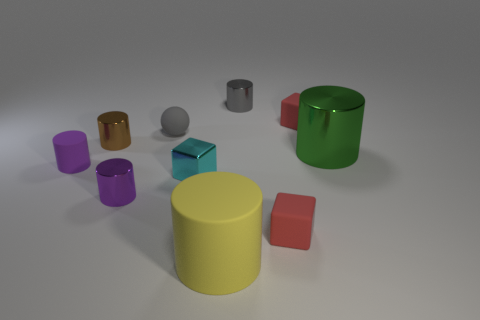Subtract all green blocks. How many purple cylinders are left? 2 Subtract 1 cubes. How many cubes are left? 2 Subtract all tiny rubber cubes. How many cubes are left? 1 Subtract all green cylinders. How many cylinders are left? 5 Subtract all red cylinders. Subtract all brown blocks. How many cylinders are left? 6 Add 3 small metallic cylinders. How many small metallic cylinders exist? 6 Subtract 0 blue cylinders. How many objects are left? 10 Subtract all cylinders. How many objects are left? 4 Subtract all yellow spheres. Subtract all large metal objects. How many objects are left? 9 Add 2 tiny purple metallic cylinders. How many tiny purple metallic cylinders are left? 3 